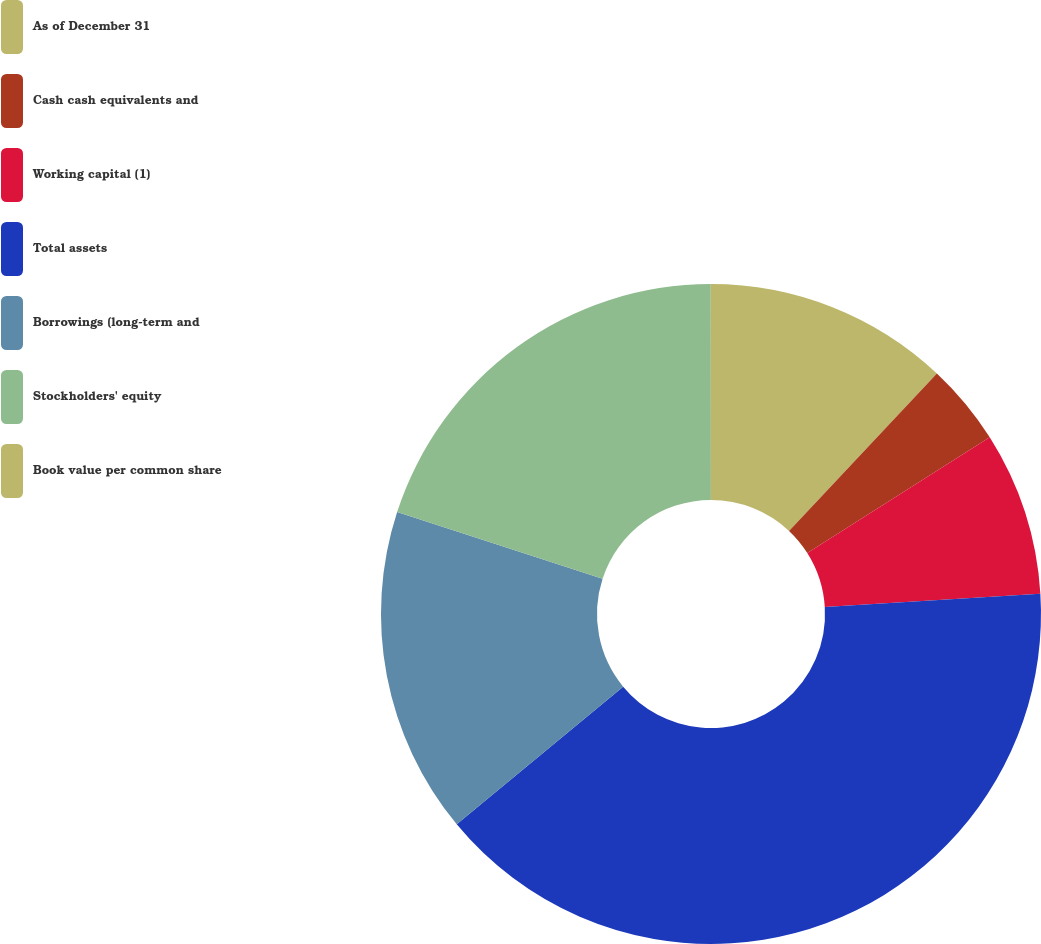Convert chart to OTSL. <chart><loc_0><loc_0><loc_500><loc_500><pie_chart><fcel>As of December 31<fcel>Cash cash equivalents and<fcel>Working capital (1)<fcel>Total assets<fcel>Borrowings (long-term and<fcel>Stockholders' equity<fcel>Book value per common share<nl><fcel>12.0%<fcel>4.01%<fcel>8.01%<fcel>39.98%<fcel>16.0%<fcel>19.99%<fcel>0.01%<nl></chart> 